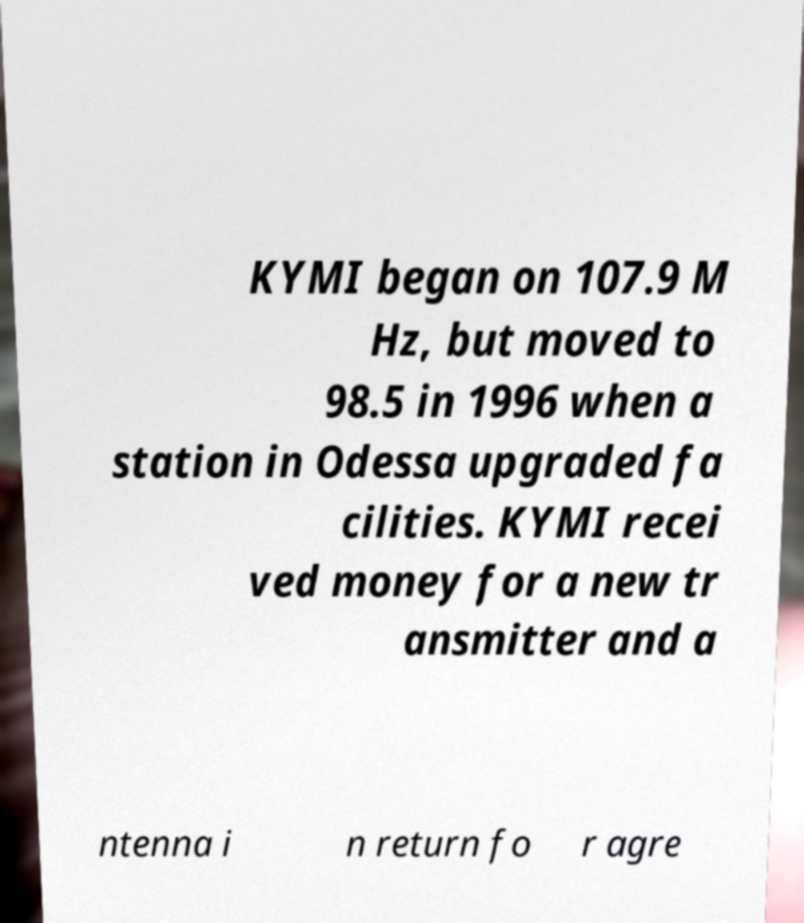There's text embedded in this image that I need extracted. Can you transcribe it verbatim? KYMI began on 107.9 M Hz, but moved to 98.5 in 1996 when a station in Odessa upgraded fa cilities. KYMI recei ved money for a new tr ansmitter and a ntenna i n return fo r agre 